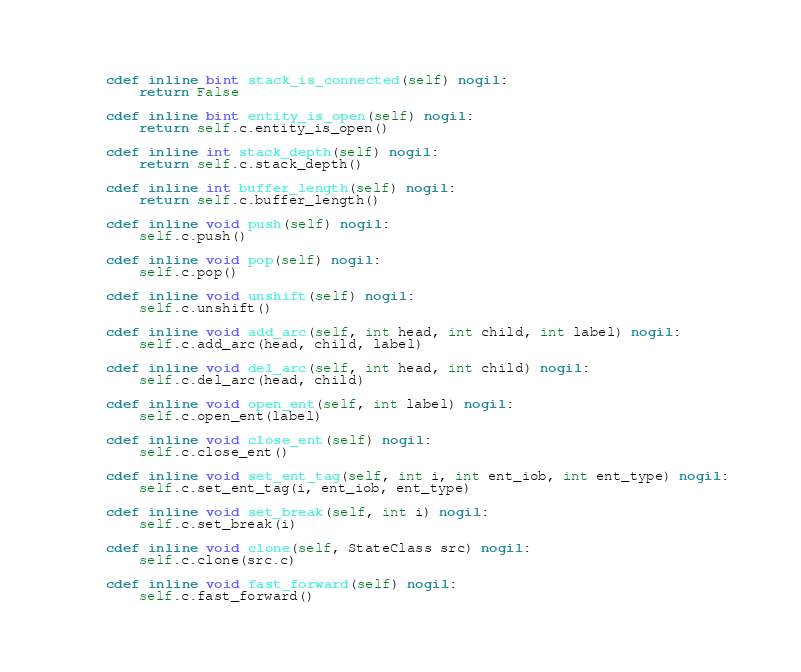Convert code to text. <code><loc_0><loc_0><loc_500><loc_500><_Cython_>
    cdef inline bint stack_is_connected(self) nogil:
        return False

    cdef inline bint entity_is_open(self) nogil:
        return self.c.entity_is_open()

    cdef inline int stack_depth(self) nogil:
        return self.c.stack_depth()

    cdef inline int buffer_length(self) nogil:
        return self.c.buffer_length()

    cdef inline void push(self) nogil:
        self.c.push()

    cdef inline void pop(self) nogil:
        self.c.pop()
    
    cdef inline void unshift(self) nogil:
        self.c.unshift()

    cdef inline void add_arc(self, int head, int child, int label) nogil:
        self.c.add_arc(head, child, label)
    
    cdef inline void del_arc(self, int head, int child) nogil:
        self.c.del_arc(head, child)

    cdef inline void open_ent(self, int label) nogil:
        self.c.open_ent(label)
    
    cdef inline void close_ent(self) nogil:
        self.c.close_ent()
    
    cdef inline void set_ent_tag(self, int i, int ent_iob, int ent_type) nogil:
        self.c.set_ent_tag(i, ent_iob, ent_type)

    cdef inline void set_break(self, int i) nogil:
        self.c.set_break(i)

    cdef inline void clone(self, StateClass src) nogil:
        self.c.clone(src.c)

    cdef inline void fast_forward(self) nogil:
        self.c.fast_forward()
</code> 